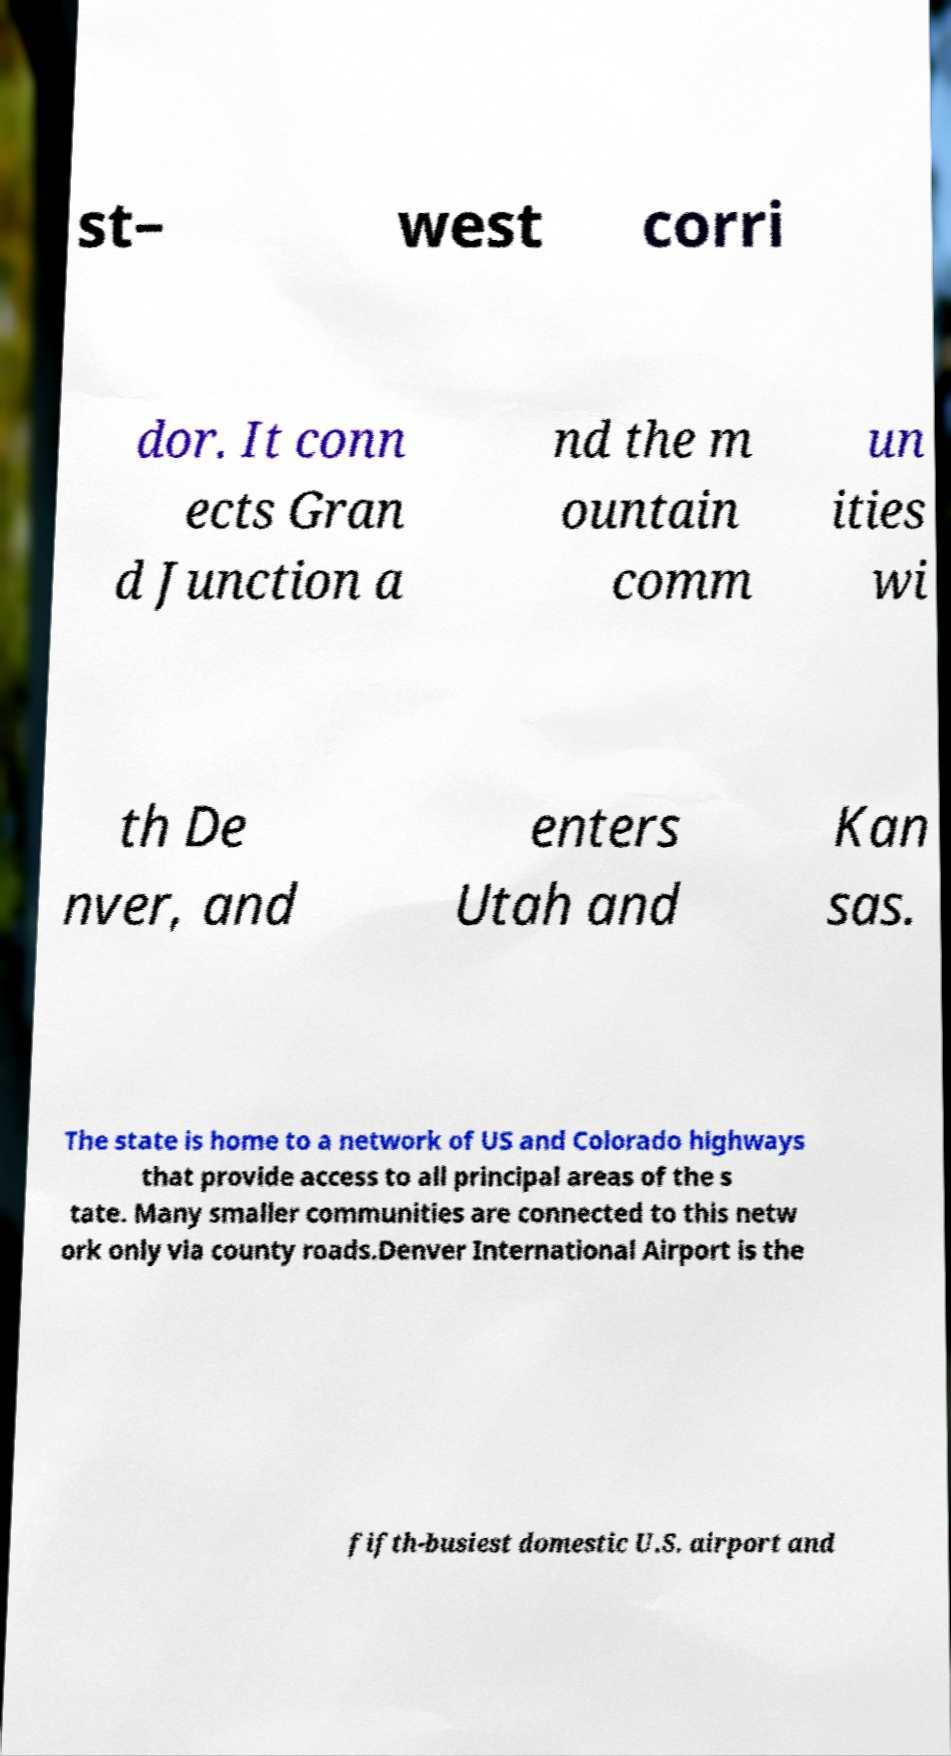Can you read and provide the text displayed in the image?This photo seems to have some interesting text. Can you extract and type it out for me? st– west corri dor. It conn ects Gran d Junction a nd the m ountain comm un ities wi th De nver, and enters Utah and Kan sas. The state is home to a network of US and Colorado highways that provide access to all principal areas of the s tate. Many smaller communities are connected to this netw ork only via county roads.Denver International Airport is the fifth-busiest domestic U.S. airport and 